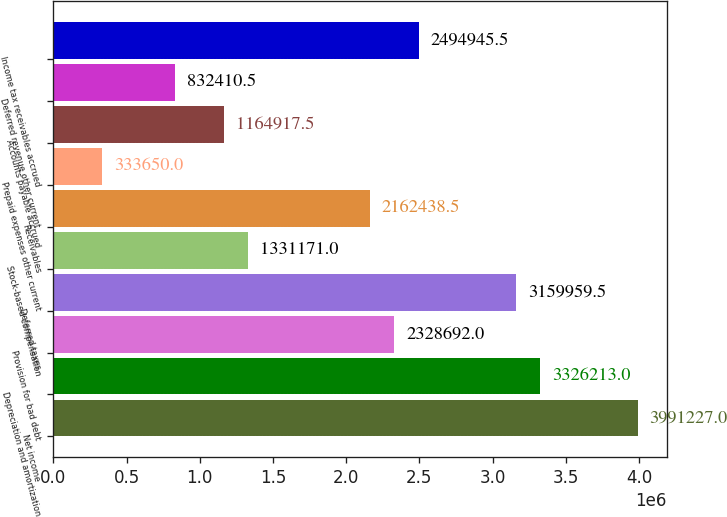Convert chart. <chart><loc_0><loc_0><loc_500><loc_500><bar_chart><fcel>Net income<fcel>Depreciation and amortization<fcel>Provision for bad debt<fcel>Deferred taxes<fcel>Stock-based compensation<fcel>Receivables<fcel>Prepaid expenses other current<fcel>Accounts payable accrued<fcel>Deferred revenue other current<fcel>Income tax receivables accrued<nl><fcel>3.99123e+06<fcel>3.32621e+06<fcel>2.32869e+06<fcel>3.15996e+06<fcel>1.33117e+06<fcel>2.16244e+06<fcel>333650<fcel>1.16492e+06<fcel>832410<fcel>2.49495e+06<nl></chart> 